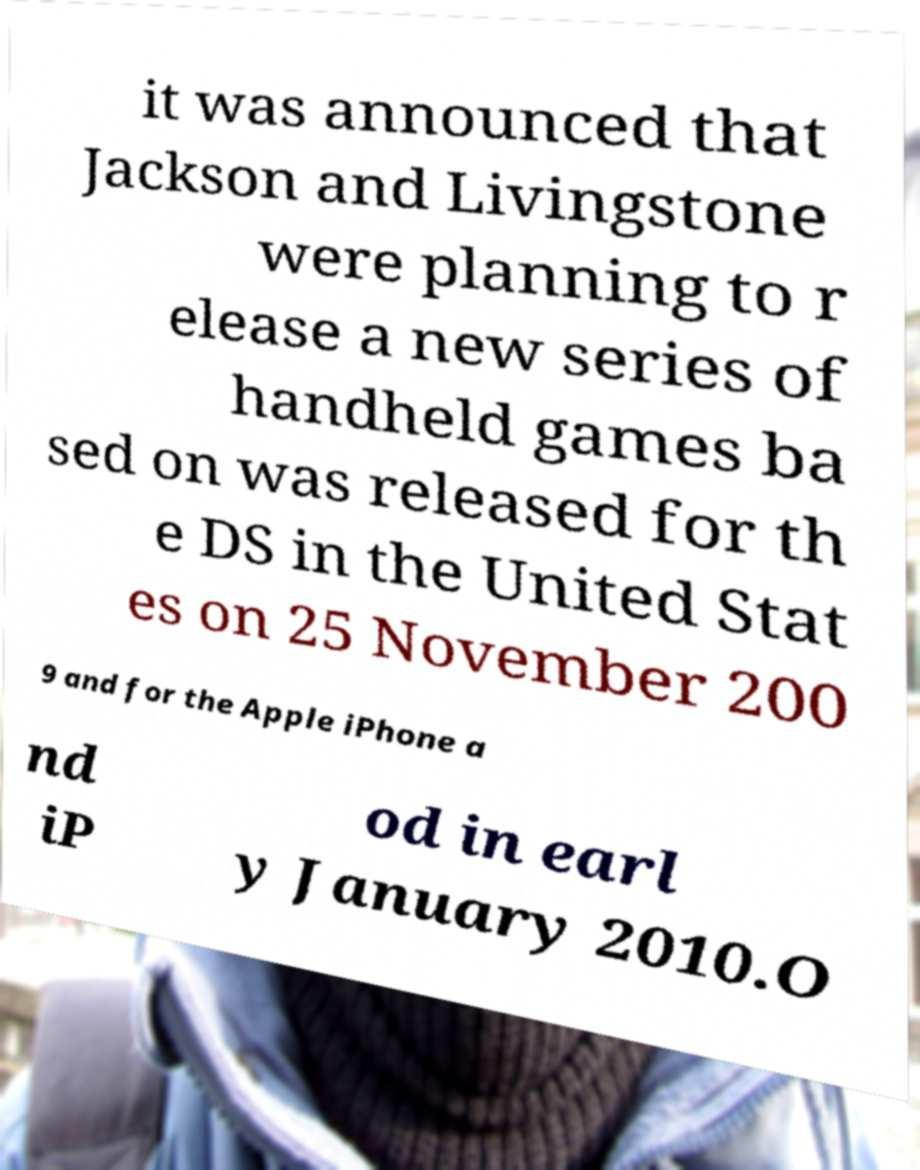I need the written content from this picture converted into text. Can you do that? it was announced that Jackson and Livingstone were planning to r elease a new series of handheld games ba sed on was released for th e DS in the United Stat es on 25 November 200 9 and for the Apple iPhone a nd iP od in earl y January 2010.O 